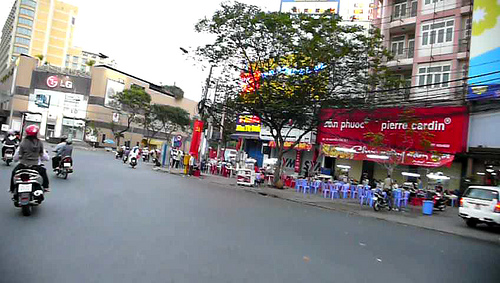Are there either any white chairs or desks? No, there are no white chairs or desks visible in this image. 